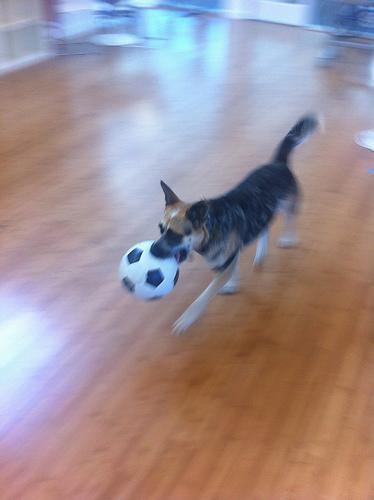How many mammals are pictured?
Give a very brief answer. 1. How many legs does the dog have?
Give a very brief answer. 4. 